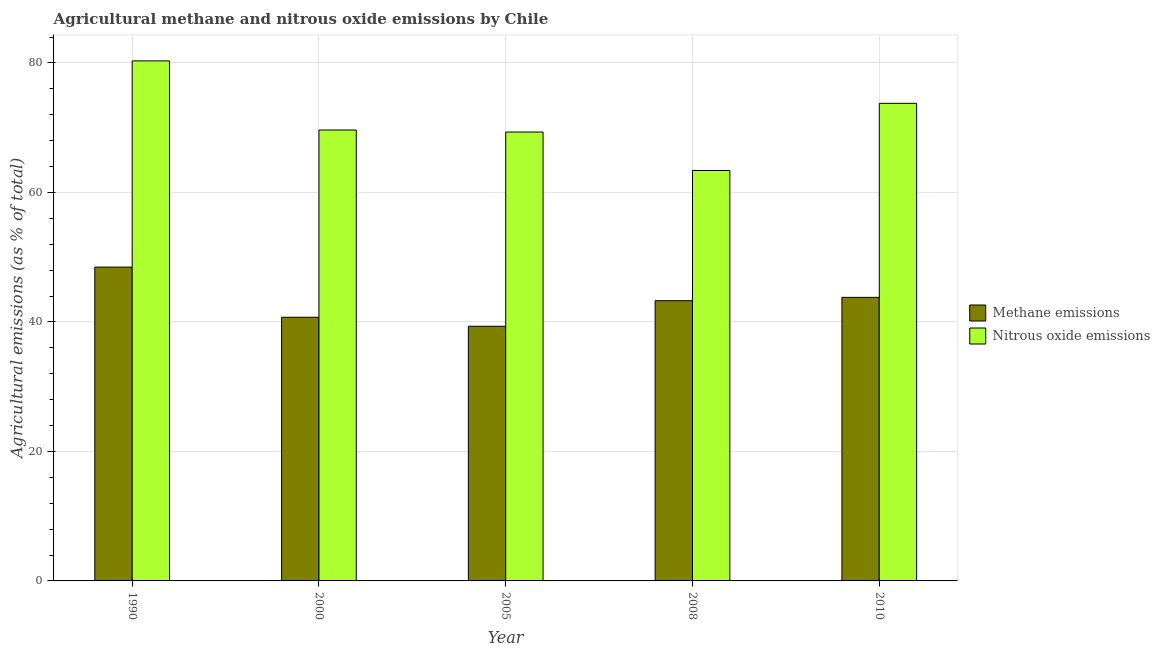How many groups of bars are there?
Keep it short and to the point. 5. Are the number of bars on each tick of the X-axis equal?
Provide a short and direct response. Yes. How many bars are there on the 3rd tick from the left?
Offer a terse response. 2. What is the amount of nitrous oxide emissions in 2010?
Provide a succinct answer. 73.77. Across all years, what is the maximum amount of methane emissions?
Your response must be concise. 48.47. Across all years, what is the minimum amount of nitrous oxide emissions?
Make the answer very short. 63.39. In which year was the amount of nitrous oxide emissions minimum?
Offer a very short reply. 2008. What is the total amount of nitrous oxide emissions in the graph?
Make the answer very short. 356.46. What is the difference between the amount of methane emissions in 1990 and that in 2010?
Your answer should be compact. 4.67. What is the difference between the amount of methane emissions in 2000 and the amount of nitrous oxide emissions in 2008?
Keep it short and to the point. -2.56. What is the average amount of methane emissions per year?
Keep it short and to the point. 43.12. In the year 1990, what is the difference between the amount of methane emissions and amount of nitrous oxide emissions?
Keep it short and to the point. 0. What is the ratio of the amount of nitrous oxide emissions in 2005 to that in 2008?
Ensure brevity in your answer.  1.09. Is the amount of methane emissions in 1990 less than that in 2010?
Your answer should be compact. No. What is the difference between the highest and the second highest amount of nitrous oxide emissions?
Give a very brief answer. 6.55. What is the difference between the highest and the lowest amount of nitrous oxide emissions?
Provide a succinct answer. 16.93. In how many years, is the amount of methane emissions greater than the average amount of methane emissions taken over all years?
Provide a succinct answer. 3. Is the sum of the amount of nitrous oxide emissions in 2005 and 2010 greater than the maximum amount of methane emissions across all years?
Provide a short and direct response. Yes. What does the 1st bar from the left in 2000 represents?
Provide a short and direct response. Methane emissions. What does the 2nd bar from the right in 2005 represents?
Make the answer very short. Methane emissions. How many bars are there?
Offer a very short reply. 10. Does the graph contain any zero values?
Ensure brevity in your answer.  No. Does the graph contain grids?
Keep it short and to the point. Yes. Where does the legend appear in the graph?
Provide a succinct answer. Center right. What is the title of the graph?
Offer a terse response. Agricultural methane and nitrous oxide emissions by Chile. Does "current US$" appear as one of the legend labels in the graph?
Offer a terse response. No. What is the label or title of the Y-axis?
Ensure brevity in your answer.  Agricultural emissions (as % of total). What is the Agricultural emissions (as % of total) in Methane emissions in 1990?
Offer a very short reply. 48.47. What is the Agricultural emissions (as % of total) of Nitrous oxide emissions in 1990?
Offer a terse response. 80.32. What is the Agricultural emissions (as % of total) in Methane emissions in 2000?
Your answer should be very brief. 40.72. What is the Agricultural emissions (as % of total) of Nitrous oxide emissions in 2000?
Give a very brief answer. 69.65. What is the Agricultural emissions (as % of total) in Methane emissions in 2005?
Ensure brevity in your answer.  39.33. What is the Agricultural emissions (as % of total) of Nitrous oxide emissions in 2005?
Ensure brevity in your answer.  69.33. What is the Agricultural emissions (as % of total) in Methane emissions in 2008?
Offer a terse response. 43.28. What is the Agricultural emissions (as % of total) in Nitrous oxide emissions in 2008?
Your answer should be very brief. 63.39. What is the Agricultural emissions (as % of total) of Methane emissions in 2010?
Ensure brevity in your answer.  43.8. What is the Agricultural emissions (as % of total) in Nitrous oxide emissions in 2010?
Make the answer very short. 73.77. Across all years, what is the maximum Agricultural emissions (as % of total) in Methane emissions?
Offer a terse response. 48.47. Across all years, what is the maximum Agricultural emissions (as % of total) in Nitrous oxide emissions?
Your answer should be compact. 80.32. Across all years, what is the minimum Agricultural emissions (as % of total) of Methane emissions?
Your answer should be very brief. 39.33. Across all years, what is the minimum Agricultural emissions (as % of total) in Nitrous oxide emissions?
Keep it short and to the point. 63.39. What is the total Agricultural emissions (as % of total) in Methane emissions in the graph?
Provide a succinct answer. 215.6. What is the total Agricultural emissions (as % of total) of Nitrous oxide emissions in the graph?
Give a very brief answer. 356.46. What is the difference between the Agricultural emissions (as % of total) in Methane emissions in 1990 and that in 2000?
Your answer should be very brief. 7.75. What is the difference between the Agricultural emissions (as % of total) in Nitrous oxide emissions in 1990 and that in 2000?
Keep it short and to the point. 10.67. What is the difference between the Agricultural emissions (as % of total) of Methane emissions in 1990 and that in 2005?
Ensure brevity in your answer.  9.14. What is the difference between the Agricultural emissions (as % of total) of Nitrous oxide emissions in 1990 and that in 2005?
Keep it short and to the point. 10.99. What is the difference between the Agricultural emissions (as % of total) of Methane emissions in 1990 and that in 2008?
Provide a succinct answer. 5.19. What is the difference between the Agricultural emissions (as % of total) in Nitrous oxide emissions in 1990 and that in 2008?
Your answer should be compact. 16.93. What is the difference between the Agricultural emissions (as % of total) of Methane emissions in 1990 and that in 2010?
Make the answer very short. 4.67. What is the difference between the Agricultural emissions (as % of total) of Nitrous oxide emissions in 1990 and that in 2010?
Your answer should be very brief. 6.55. What is the difference between the Agricultural emissions (as % of total) in Methane emissions in 2000 and that in 2005?
Provide a short and direct response. 1.39. What is the difference between the Agricultural emissions (as % of total) of Nitrous oxide emissions in 2000 and that in 2005?
Provide a short and direct response. 0.32. What is the difference between the Agricultural emissions (as % of total) in Methane emissions in 2000 and that in 2008?
Ensure brevity in your answer.  -2.56. What is the difference between the Agricultural emissions (as % of total) in Nitrous oxide emissions in 2000 and that in 2008?
Keep it short and to the point. 6.25. What is the difference between the Agricultural emissions (as % of total) in Methane emissions in 2000 and that in 2010?
Ensure brevity in your answer.  -3.07. What is the difference between the Agricultural emissions (as % of total) of Nitrous oxide emissions in 2000 and that in 2010?
Offer a very short reply. -4.12. What is the difference between the Agricultural emissions (as % of total) in Methane emissions in 2005 and that in 2008?
Provide a short and direct response. -3.95. What is the difference between the Agricultural emissions (as % of total) of Nitrous oxide emissions in 2005 and that in 2008?
Provide a succinct answer. 5.94. What is the difference between the Agricultural emissions (as % of total) of Methane emissions in 2005 and that in 2010?
Offer a very short reply. -4.46. What is the difference between the Agricultural emissions (as % of total) of Nitrous oxide emissions in 2005 and that in 2010?
Your answer should be compact. -4.44. What is the difference between the Agricultural emissions (as % of total) of Methane emissions in 2008 and that in 2010?
Your answer should be very brief. -0.51. What is the difference between the Agricultural emissions (as % of total) of Nitrous oxide emissions in 2008 and that in 2010?
Your answer should be very brief. -10.37. What is the difference between the Agricultural emissions (as % of total) in Methane emissions in 1990 and the Agricultural emissions (as % of total) in Nitrous oxide emissions in 2000?
Your answer should be very brief. -21.18. What is the difference between the Agricultural emissions (as % of total) in Methane emissions in 1990 and the Agricultural emissions (as % of total) in Nitrous oxide emissions in 2005?
Offer a very short reply. -20.86. What is the difference between the Agricultural emissions (as % of total) of Methane emissions in 1990 and the Agricultural emissions (as % of total) of Nitrous oxide emissions in 2008?
Give a very brief answer. -14.92. What is the difference between the Agricultural emissions (as % of total) of Methane emissions in 1990 and the Agricultural emissions (as % of total) of Nitrous oxide emissions in 2010?
Ensure brevity in your answer.  -25.3. What is the difference between the Agricultural emissions (as % of total) in Methane emissions in 2000 and the Agricultural emissions (as % of total) in Nitrous oxide emissions in 2005?
Provide a succinct answer. -28.61. What is the difference between the Agricultural emissions (as % of total) in Methane emissions in 2000 and the Agricultural emissions (as % of total) in Nitrous oxide emissions in 2008?
Your response must be concise. -22.67. What is the difference between the Agricultural emissions (as % of total) in Methane emissions in 2000 and the Agricultural emissions (as % of total) in Nitrous oxide emissions in 2010?
Offer a very short reply. -33.04. What is the difference between the Agricultural emissions (as % of total) in Methane emissions in 2005 and the Agricultural emissions (as % of total) in Nitrous oxide emissions in 2008?
Make the answer very short. -24.06. What is the difference between the Agricultural emissions (as % of total) in Methane emissions in 2005 and the Agricultural emissions (as % of total) in Nitrous oxide emissions in 2010?
Offer a very short reply. -34.43. What is the difference between the Agricultural emissions (as % of total) in Methane emissions in 2008 and the Agricultural emissions (as % of total) in Nitrous oxide emissions in 2010?
Give a very brief answer. -30.49. What is the average Agricultural emissions (as % of total) of Methane emissions per year?
Your answer should be very brief. 43.12. What is the average Agricultural emissions (as % of total) in Nitrous oxide emissions per year?
Keep it short and to the point. 71.29. In the year 1990, what is the difference between the Agricultural emissions (as % of total) in Methane emissions and Agricultural emissions (as % of total) in Nitrous oxide emissions?
Your answer should be very brief. -31.85. In the year 2000, what is the difference between the Agricultural emissions (as % of total) of Methane emissions and Agricultural emissions (as % of total) of Nitrous oxide emissions?
Offer a very short reply. -28.93. In the year 2005, what is the difference between the Agricultural emissions (as % of total) in Methane emissions and Agricultural emissions (as % of total) in Nitrous oxide emissions?
Offer a terse response. -30. In the year 2008, what is the difference between the Agricultural emissions (as % of total) of Methane emissions and Agricultural emissions (as % of total) of Nitrous oxide emissions?
Give a very brief answer. -20.11. In the year 2010, what is the difference between the Agricultural emissions (as % of total) in Methane emissions and Agricultural emissions (as % of total) in Nitrous oxide emissions?
Your response must be concise. -29.97. What is the ratio of the Agricultural emissions (as % of total) of Methane emissions in 1990 to that in 2000?
Ensure brevity in your answer.  1.19. What is the ratio of the Agricultural emissions (as % of total) in Nitrous oxide emissions in 1990 to that in 2000?
Your answer should be compact. 1.15. What is the ratio of the Agricultural emissions (as % of total) in Methane emissions in 1990 to that in 2005?
Your response must be concise. 1.23. What is the ratio of the Agricultural emissions (as % of total) in Nitrous oxide emissions in 1990 to that in 2005?
Ensure brevity in your answer.  1.16. What is the ratio of the Agricultural emissions (as % of total) of Methane emissions in 1990 to that in 2008?
Provide a succinct answer. 1.12. What is the ratio of the Agricultural emissions (as % of total) in Nitrous oxide emissions in 1990 to that in 2008?
Offer a terse response. 1.27. What is the ratio of the Agricultural emissions (as % of total) of Methane emissions in 1990 to that in 2010?
Ensure brevity in your answer.  1.11. What is the ratio of the Agricultural emissions (as % of total) in Nitrous oxide emissions in 1990 to that in 2010?
Offer a terse response. 1.09. What is the ratio of the Agricultural emissions (as % of total) of Methane emissions in 2000 to that in 2005?
Make the answer very short. 1.04. What is the ratio of the Agricultural emissions (as % of total) of Nitrous oxide emissions in 2000 to that in 2005?
Provide a succinct answer. 1. What is the ratio of the Agricultural emissions (as % of total) in Methane emissions in 2000 to that in 2008?
Ensure brevity in your answer.  0.94. What is the ratio of the Agricultural emissions (as % of total) in Nitrous oxide emissions in 2000 to that in 2008?
Offer a very short reply. 1.1. What is the ratio of the Agricultural emissions (as % of total) of Methane emissions in 2000 to that in 2010?
Your answer should be compact. 0.93. What is the ratio of the Agricultural emissions (as % of total) in Nitrous oxide emissions in 2000 to that in 2010?
Offer a very short reply. 0.94. What is the ratio of the Agricultural emissions (as % of total) in Methane emissions in 2005 to that in 2008?
Give a very brief answer. 0.91. What is the ratio of the Agricultural emissions (as % of total) of Nitrous oxide emissions in 2005 to that in 2008?
Ensure brevity in your answer.  1.09. What is the ratio of the Agricultural emissions (as % of total) in Methane emissions in 2005 to that in 2010?
Keep it short and to the point. 0.9. What is the ratio of the Agricultural emissions (as % of total) of Nitrous oxide emissions in 2005 to that in 2010?
Offer a very short reply. 0.94. What is the ratio of the Agricultural emissions (as % of total) in Methane emissions in 2008 to that in 2010?
Provide a succinct answer. 0.99. What is the ratio of the Agricultural emissions (as % of total) in Nitrous oxide emissions in 2008 to that in 2010?
Give a very brief answer. 0.86. What is the difference between the highest and the second highest Agricultural emissions (as % of total) of Methane emissions?
Make the answer very short. 4.67. What is the difference between the highest and the second highest Agricultural emissions (as % of total) in Nitrous oxide emissions?
Provide a succinct answer. 6.55. What is the difference between the highest and the lowest Agricultural emissions (as % of total) in Methane emissions?
Your answer should be very brief. 9.14. What is the difference between the highest and the lowest Agricultural emissions (as % of total) of Nitrous oxide emissions?
Offer a very short reply. 16.93. 